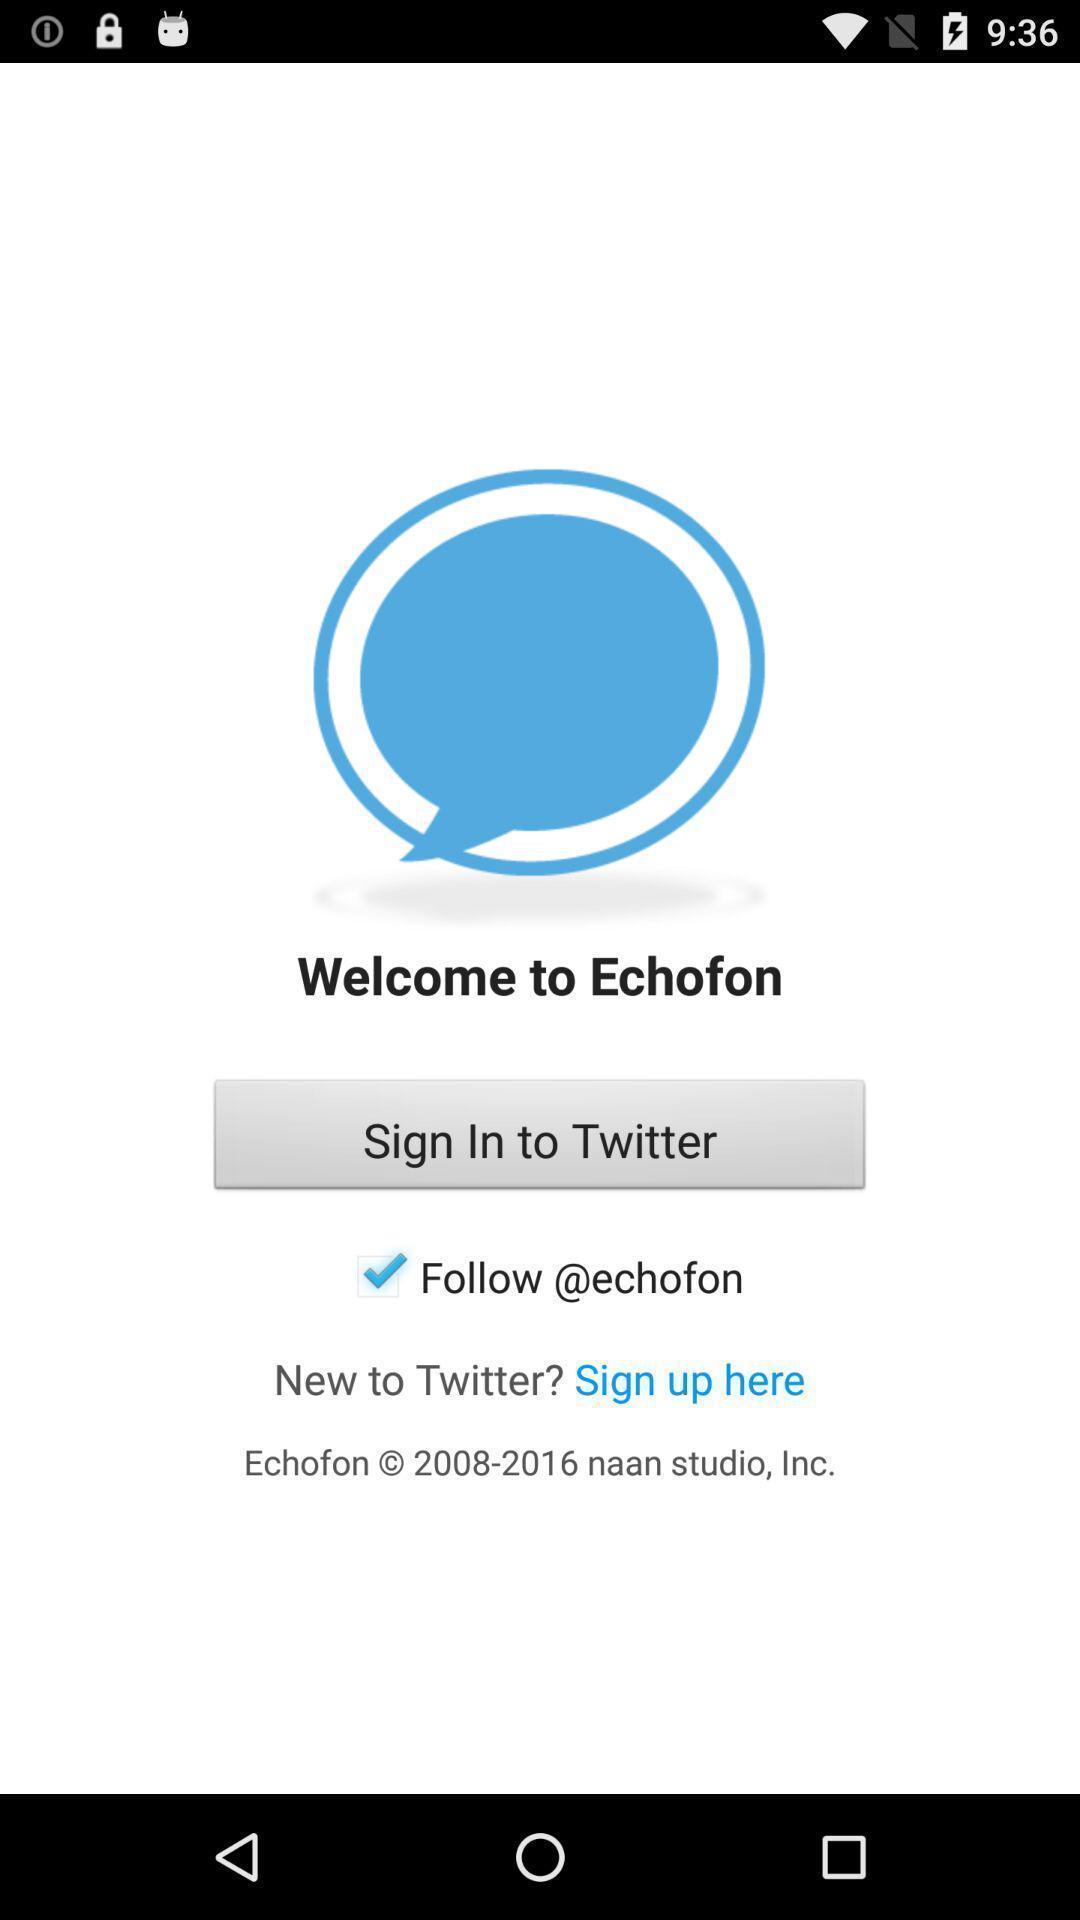Summarize the main components in this picture. Window displaying a social app. 